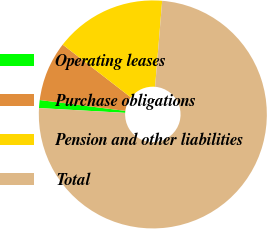Convert chart to OTSL. <chart><loc_0><loc_0><loc_500><loc_500><pie_chart><fcel>Operating leases<fcel>Purchase obligations<fcel>Pension and other liabilities<fcel>Total<nl><fcel>1.13%<fcel>8.47%<fcel>15.82%<fcel>74.58%<nl></chart> 